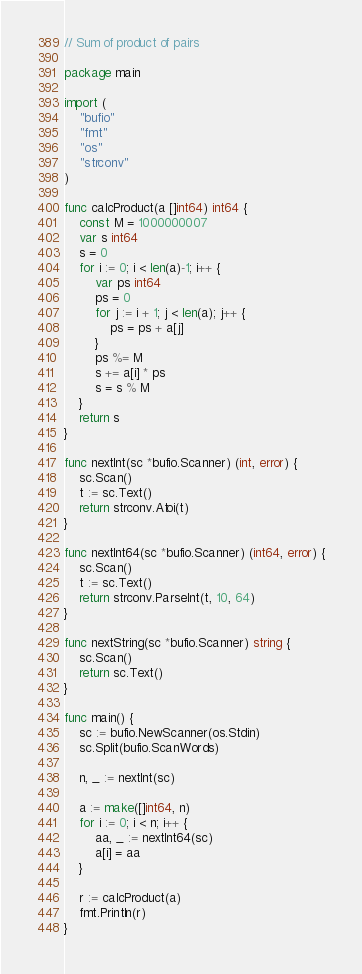Convert code to text. <code><loc_0><loc_0><loc_500><loc_500><_Go_>// Sum of product of pairs

package main

import (
	"bufio"
	"fmt"
	"os"
	"strconv"
)

func calcProduct(a []int64) int64 {
	const M = 1000000007
	var s int64
	s = 0
	for i := 0; i < len(a)-1; i++ {
		var ps int64
		ps = 0
		for j := i + 1; j < len(a); j++ {
			ps = ps + a[j]
		}
		ps %= M
		s += a[i] * ps
		s = s % M
	}
	return s
}

func nextInt(sc *bufio.Scanner) (int, error) {
	sc.Scan()
	t := sc.Text()
	return strconv.Atoi(t)
}

func nextInt64(sc *bufio.Scanner) (int64, error) {
	sc.Scan()
	t := sc.Text()
	return strconv.ParseInt(t, 10, 64)
}

func nextString(sc *bufio.Scanner) string {
	sc.Scan()
	return sc.Text()
}

func main() {
	sc := bufio.NewScanner(os.Stdin)
	sc.Split(bufio.ScanWords)

	n, _ := nextInt(sc)

	a := make([]int64, n)
	for i := 0; i < n; i++ {
		aa, _ := nextInt64(sc)
		a[i] = aa
	}

	r := calcProduct(a)
	fmt.Println(r)
}
</code> 